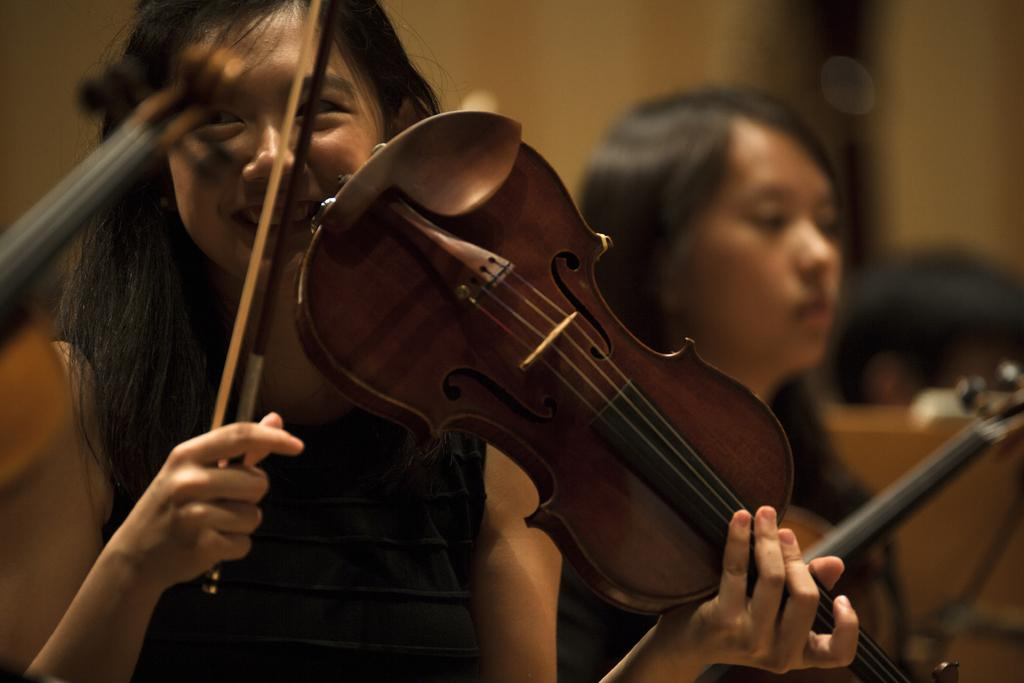How many people are in the image? There are two women in the image. What are the women holding in the image? Each woman is holding a violin. How many bikes are visible in the image? There are no bikes visible in the image. What type of straw is being used by the women in the image? There is no straw present in the image; the women are holding violins. 